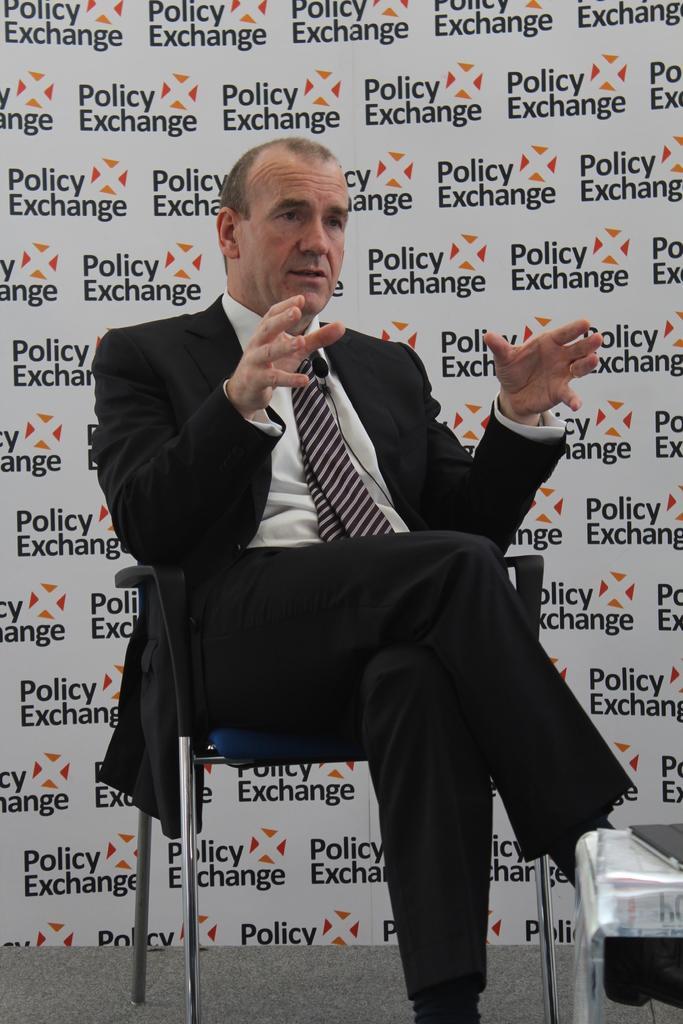How would you summarize this image in a sentence or two? Here in this picture we can see a person in a black colored suit sitting on a chair and behind him we can see a banner present and we can see he is speaking something in the microphone present with him and in front of him we can see a table, on which we can see a book present. 